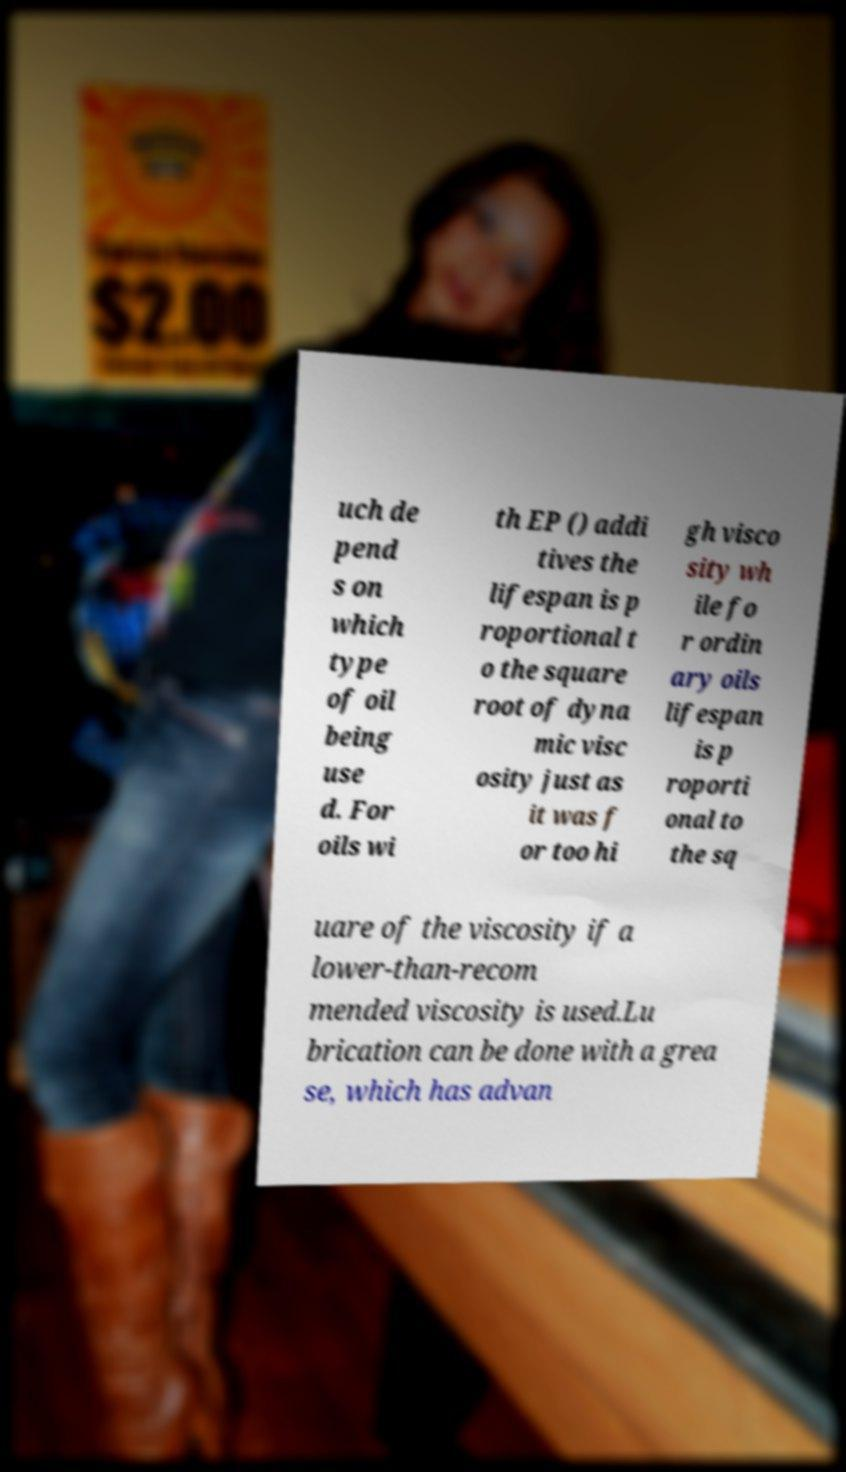Please read and relay the text visible in this image. What does it say? uch de pend s on which type of oil being use d. For oils wi th EP () addi tives the lifespan is p roportional t o the square root of dyna mic visc osity just as it was f or too hi gh visco sity wh ile fo r ordin ary oils lifespan is p roporti onal to the sq uare of the viscosity if a lower-than-recom mended viscosity is used.Lu brication can be done with a grea se, which has advan 